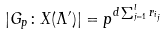<formula> <loc_0><loc_0><loc_500><loc_500>| G _ { p } \colon X ( \Lambda ^ { \prime } ) | = p ^ { d \sum _ { j = 1 } ^ { l } r _ { i _ { j } } }</formula> 